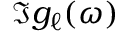Convert formula to latex. <formula><loc_0><loc_0><loc_500><loc_500>\Im { g _ { \ell } ( \omega ) }</formula> 